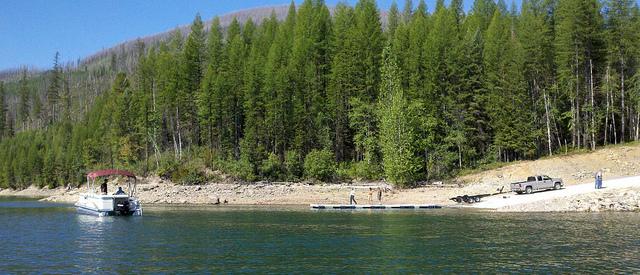Where is this place?
Keep it brief. Lake. How is the sky?
Give a very brief answer. Clear. Where are the boats?
Be succinct. Water. Was this photo taken near mountains?
Give a very brief answer. Yes. What type of boat is on the water?
Keep it brief. Pontoon. Is the sky clear?
Answer briefly. Yes. 